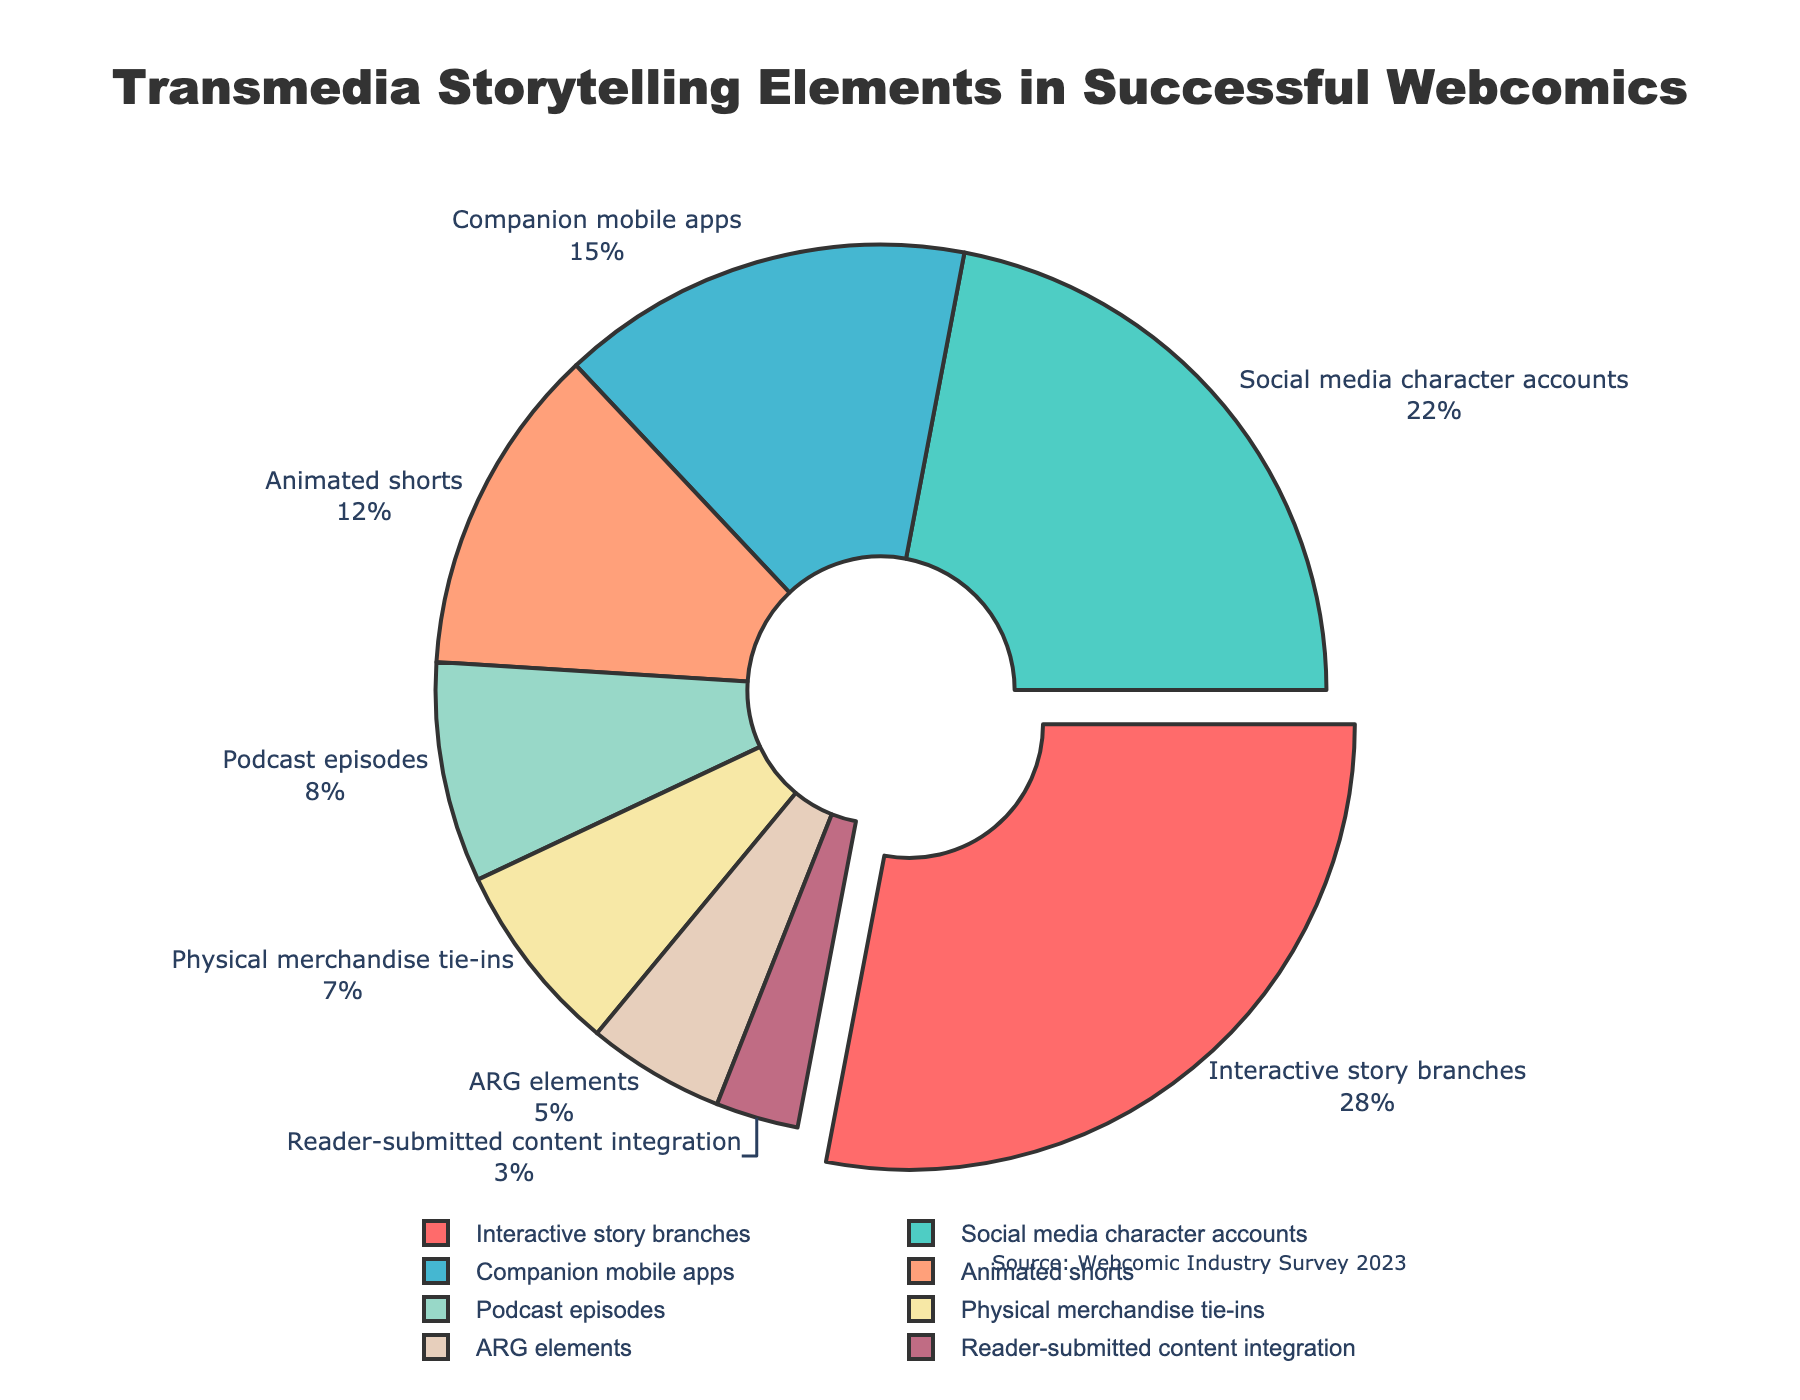Which transmedia storytelling element is utilized the most in successful webcomics? By examining the pie chart, we identify the segment with the highest percentage. The "Interactive story branches" segment is highlighted by being slightly pulled out from the pie, indicating its dominance. It accounts for 28%.
Answer: Interactive story branches What is the combined percentage of "Podcast episodes" and "Physical merchandise tie-ins"? From the pie chart, we locate "Podcast episodes" which is 8% and "Physical merchandise tie-ins" which is 7%. Adding these percentages together gives us 8% + 7% = 15%.
Answer: 15% How does the use of "Social media character accounts" compare to "Companion mobile apps"? The pie chart shows "Social media character accounts" at 22% and "Companion mobile apps" at 15%. Comparing these, "Social media character accounts" is 7% higher.
Answer: Social media character accounts is 7% higher Which element has the smallest representation in the chart? The smallest segment on the pie chart corresponds to the element with the lowest percentage. "Reader-submitted content integration" is the smallest, with 3%.
Answer: Reader-submitted content integration What percentage of successful webcomics use "ARG elements" and "Animated shorts" combined? From the pie chart, "ARG elements" are at 5% and "Animated shorts" are at 12%. Adding these gives us 5% + 12% = 17%.
Answer: 17% Which two elements together make up more than half of the total percentage? To determine this, look for combinations summing to more than 50%. "Interactive story branches" (28%) and "Social media character accounts" (22%) together total 28% + 22% = 50%. Since they don't exceed 50%, consider combinations with another element. "Interactive story branches" and "Companion mobile apps" combined with anything else falls short. Thus, the correct pair is "Interactive story branches" (28%) and "Social media character accounts" (22%) along with any small element.
Answer: Interactive story branches and Social media character accounts What is the visual attribute of the segment with the highest percentage? The segment with the highest percentage (Interactive story branches) is visually identified as being slightly pulled out from the center of the pie chart, indicating its prominence.
Answer: Pulled out from the center 